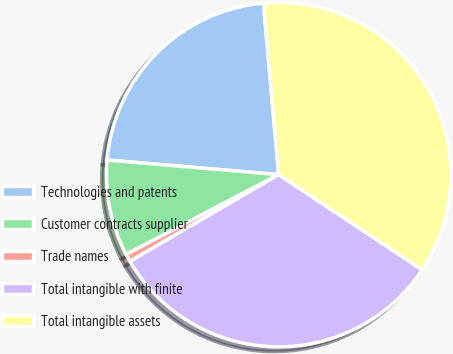Convert chart. <chart><loc_0><loc_0><loc_500><loc_500><pie_chart><fcel>Technologies and patents<fcel>Customer contracts supplier<fcel>Trade names<fcel>Total intangible with finite<fcel>Total intangible assets<nl><fcel>22.24%<fcel>9.02%<fcel>0.73%<fcel>32.27%<fcel>35.73%<nl></chart> 